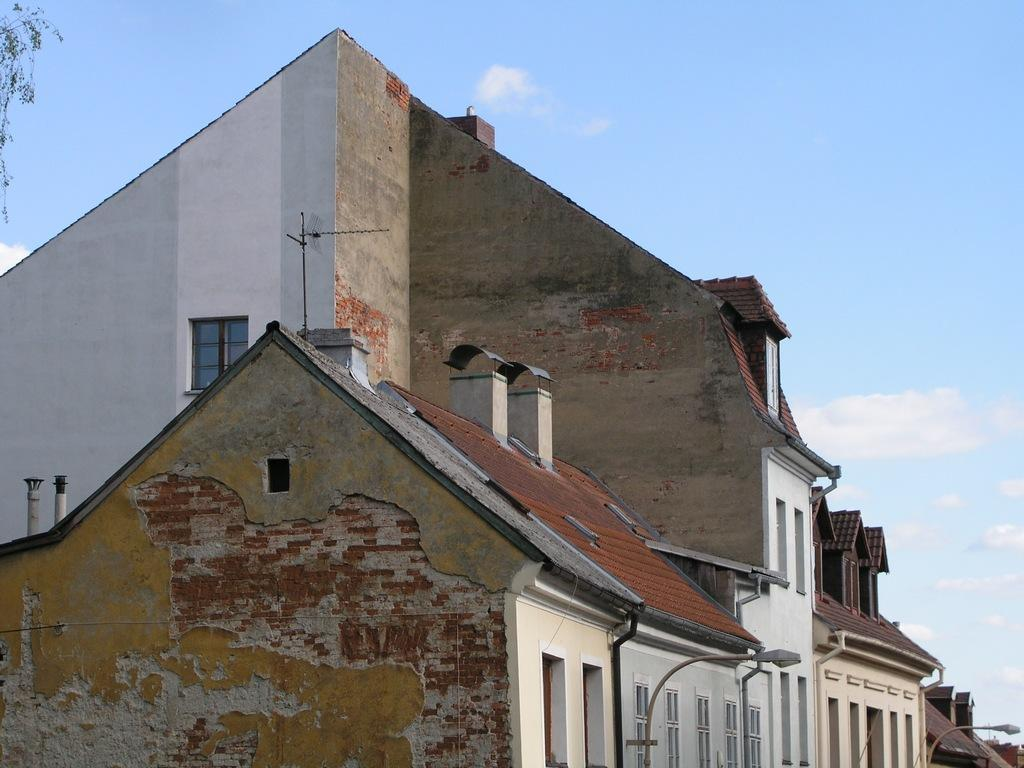What type of structures can be seen in the image? There are buildings in the image. What else is visible in the image besides the buildings? There are lights and poles in the image. What can be seen in the background of the image? The sky is visible in the background of the image. What type of vegetation is present in the top left side of the image? Leaves are present in the top left side of the image. How many cars are parked near the buildings in the image? There is no mention of cars in the image; only buildings, lights, poles, the sky, and leaves are present. Can you tell me how many people are swimming in the image? There is no swimming activity depicted in the image. 